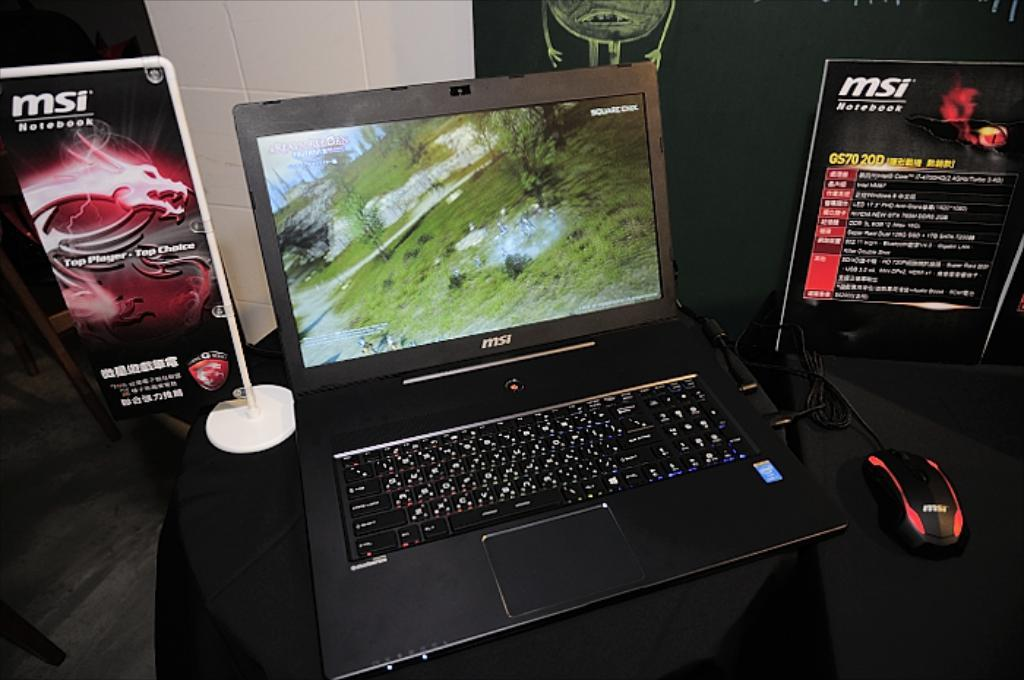Provide a one-sentence caption for the provided image. An open MSI laptop sitting on a black table between two MSI advertising signs. 